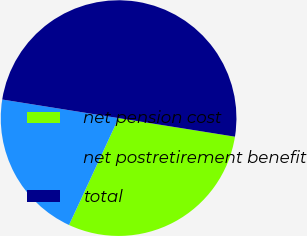Convert chart to OTSL. <chart><loc_0><loc_0><loc_500><loc_500><pie_chart><fcel>net pension cost<fcel>net postretirement benefit<fcel>total<nl><fcel>29.39%<fcel>20.61%<fcel>50.0%<nl></chart> 